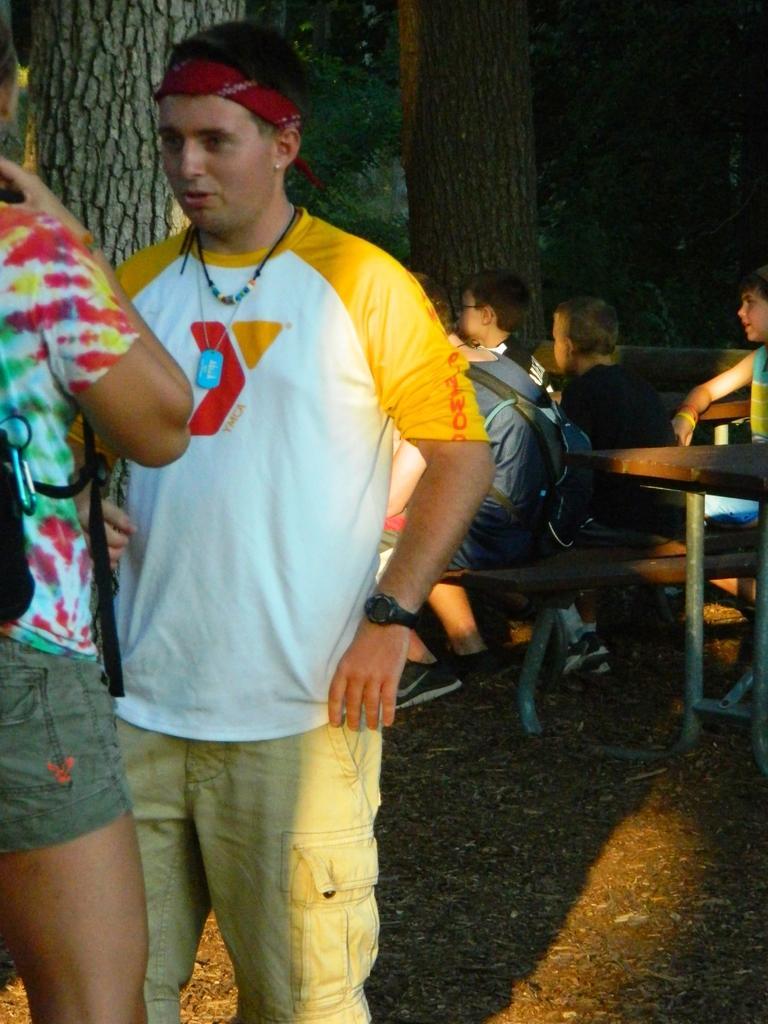Describe this image in one or two sentences. A man wearing a white , yellow t shirt is having a head band and watch. He is standing and talking to a person standing in front of him. Beside him there are many person sitting on chairs and tables. There are trees in the background. 